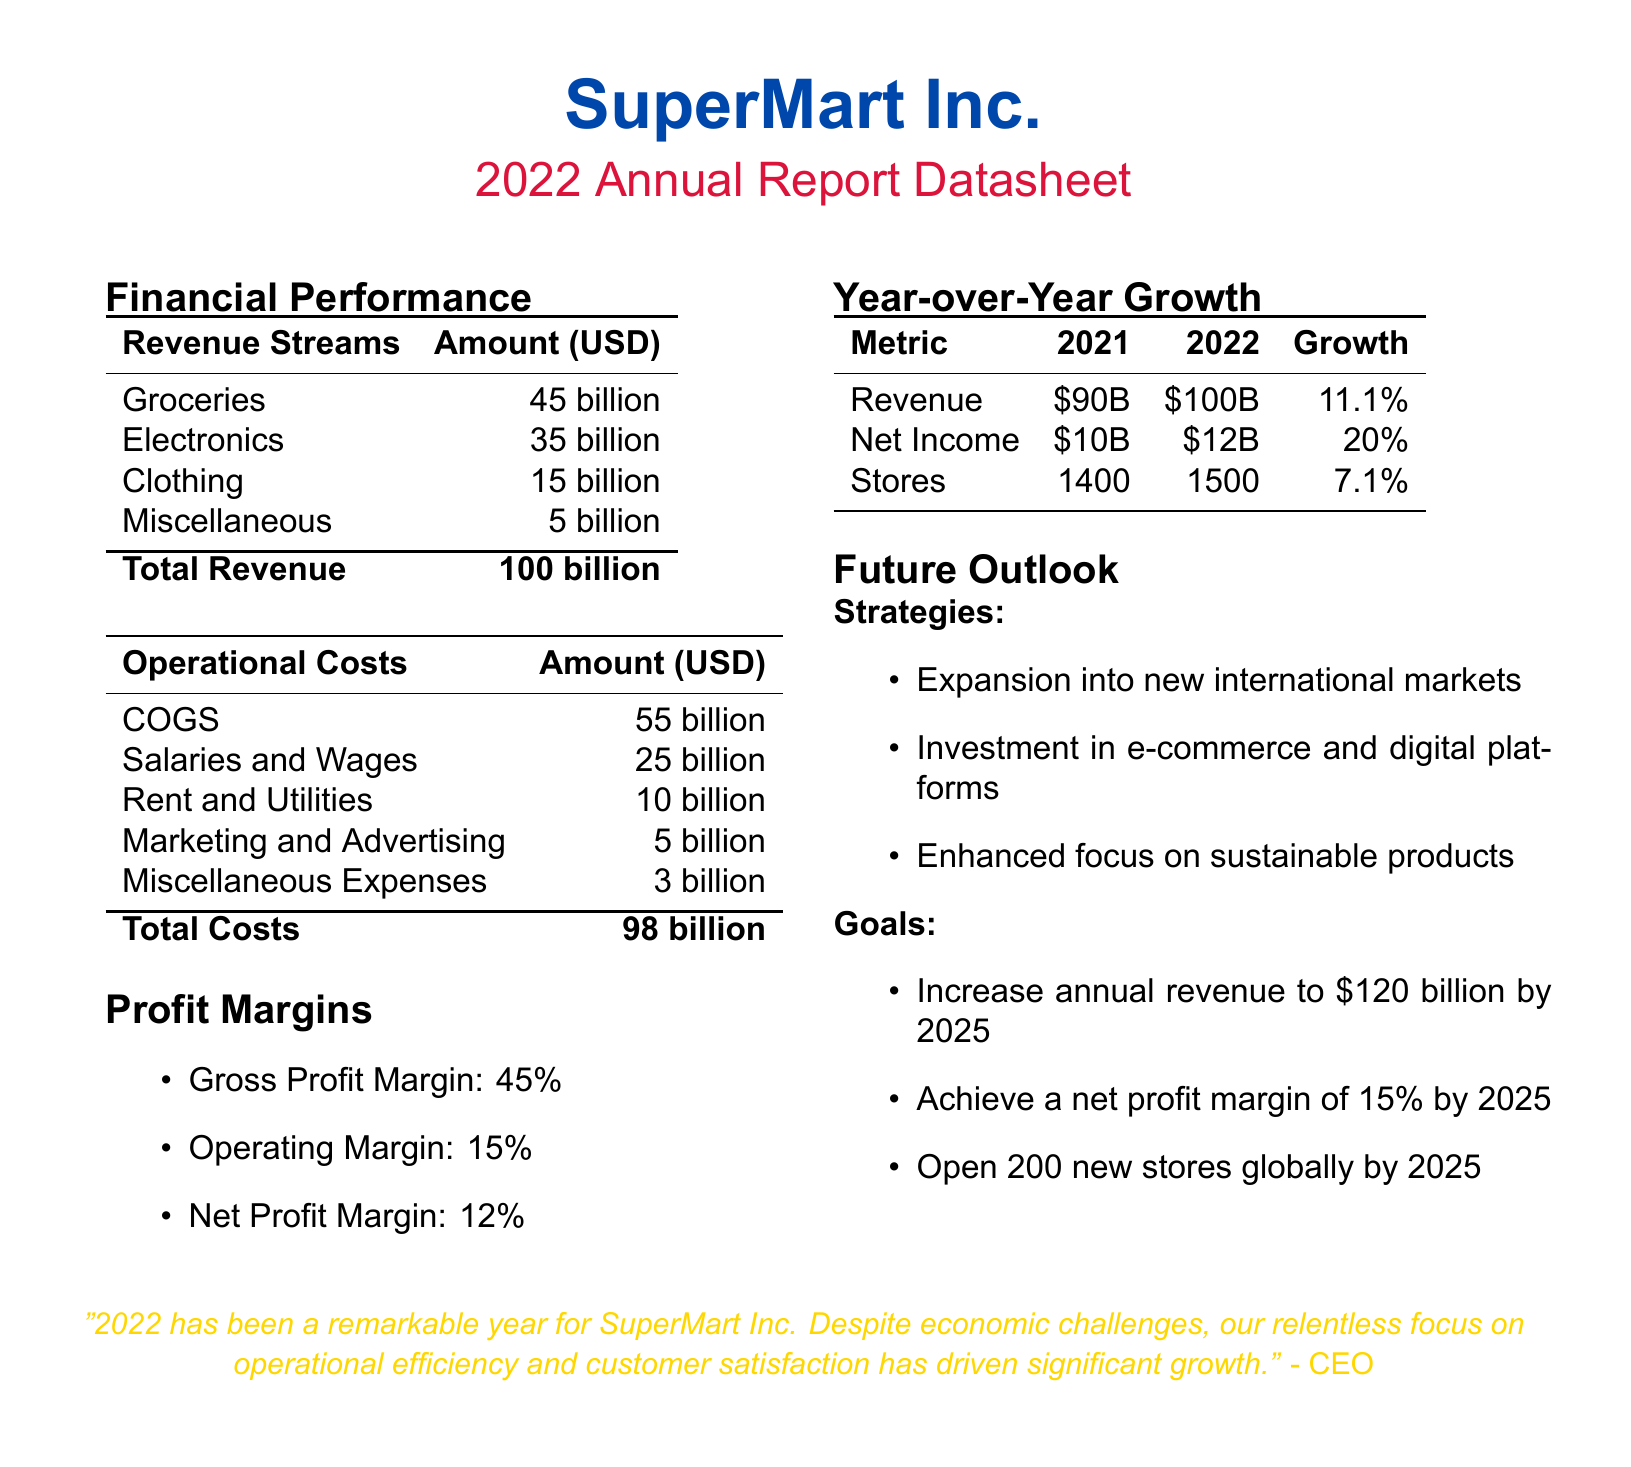What was the total revenue for 2022? The total revenue is listed in the document as 100 billion USD.
Answer: 100 billion What is the net profit margin for SuperMart Inc.? The net profit margin can be found in the profit margins section, which is 12%.
Answer: 12% What was the year-over-year growth in revenue from 2021 to 2022? The growth in revenue is calculated from the revenue figures provided for 2021 and 2022, which shows an increase of 11.1%.
Answer: 11.1% What are the operational costs related to salaries and wages? The salaries and wages figure can be retrieved directly from the operational costs table, which states 25 billion.
Answer: 25 billion How many new stores does SuperMart Inc. plan to open by 2025? The goal for store openings is explicitly mentioned in the future outlook section, which states 200 new stores.
Answer: 200 What was the total operational cost for 2022? The total operational cost is the aggregate of all listed costs, which is 98 billion USD.
Answer: 98 billion What percentage of the gross profit margin did SuperMart Inc. achieve? The gross profit margin is explicitly stated in the profit margins section as 45%.
Answer: 45% What is one of the strategies mentioned for future growth? The document lists several strategies, one of which includes "Expansion into new international markets."
Answer: Expansion into new international markets What was the net income for 2022? The net income for 2022 is specifically mentioned in the year-over-year growth table as 12 billion USD.
Answer: 12 billion 